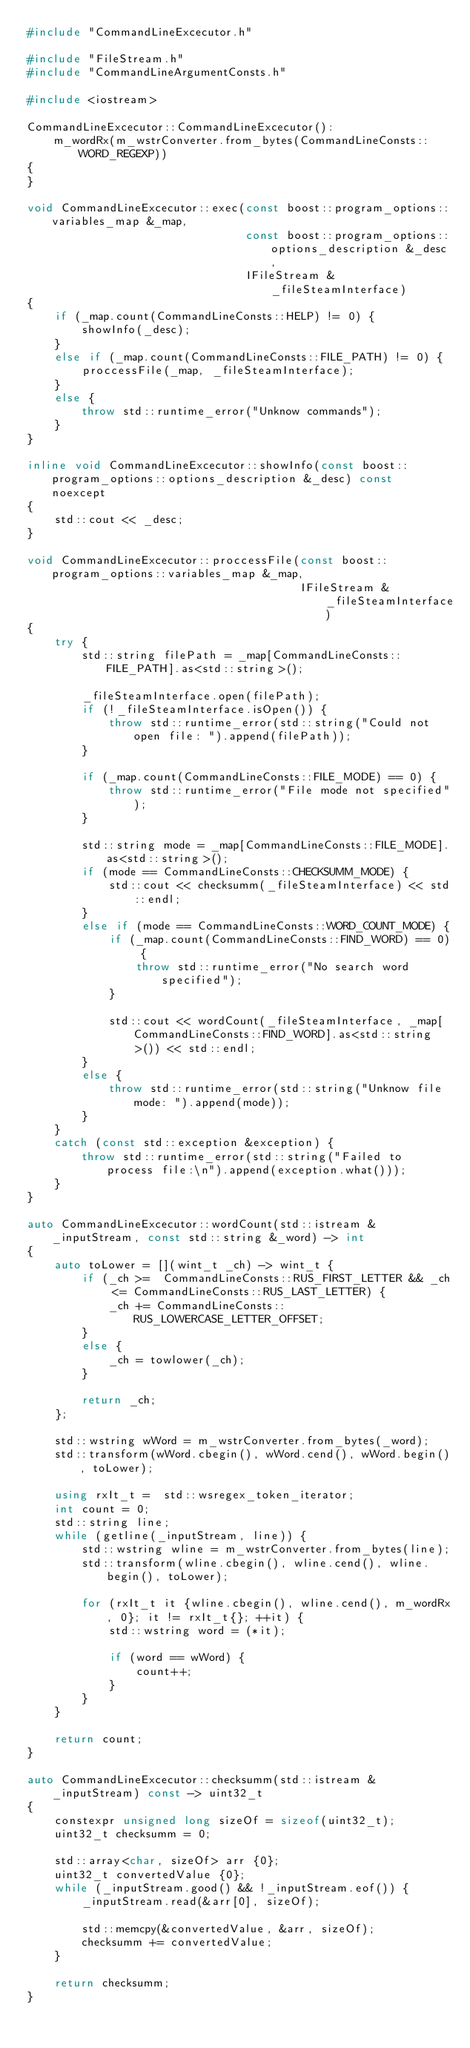<code> <loc_0><loc_0><loc_500><loc_500><_C++_>#include "CommandLineExcecutor.h"

#include "FileStream.h"
#include "CommandLineArgumentConsts.h"

#include <iostream>

CommandLineExcecutor::CommandLineExcecutor():
    m_wordRx(m_wstrConverter.from_bytes(CommandLineConsts::WORD_REGEXP))
{
}

void CommandLineExcecutor::exec(const boost::program_options::variables_map &_map,
                                const boost::program_options::options_description &_desc,
                                IFileStream &_fileSteamInterface)
{
    if (_map.count(CommandLineConsts::HELP) != 0) {
        showInfo(_desc);
    }
    else if (_map.count(CommandLineConsts::FILE_PATH) != 0) {
        proccessFile(_map, _fileSteamInterface);
    }
    else {
        throw std::runtime_error("Unknow commands");
    }
}

inline void CommandLineExcecutor::showInfo(const boost::program_options::options_description &_desc) const noexcept
{
    std::cout << _desc;
}

void CommandLineExcecutor::proccessFile(const boost::program_options::variables_map &_map,
                                        IFileStream &_fileSteamInterface)
{
    try {
        std::string filePath = _map[CommandLineConsts::FILE_PATH].as<std::string>();

        _fileSteamInterface.open(filePath);
        if (!_fileSteamInterface.isOpen()) {
            throw std::runtime_error(std::string("Could not open file: ").append(filePath));
        }

        if (_map.count(CommandLineConsts::FILE_MODE) == 0) {
            throw std::runtime_error("File mode not specified");
        }

        std::string mode = _map[CommandLineConsts::FILE_MODE].as<std::string>();
        if (mode == CommandLineConsts::CHECKSUMM_MODE) {
            std::cout << checksumm(_fileSteamInterface) << std::endl;
        }
        else if (mode == CommandLineConsts::WORD_COUNT_MODE) {
            if (_map.count(CommandLineConsts::FIND_WORD) == 0) {
                throw std::runtime_error("No search word specified");
            }

            std::cout << wordCount(_fileSteamInterface, _map[CommandLineConsts::FIND_WORD].as<std::string>()) << std::endl;
        }
        else {
            throw std::runtime_error(std::string("Unknow file mode: ").append(mode));
        }
    }
    catch (const std::exception &exception) {
        throw std::runtime_error(std::string("Failed to process file:\n").append(exception.what()));
    }
}

auto CommandLineExcecutor::wordCount(std::istream &_inputStream, const std::string &_word) -> int
{
    auto toLower = [](wint_t _ch) -> wint_t {
        if (_ch >=  CommandLineConsts::RUS_FIRST_LETTER && _ch <= CommandLineConsts::RUS_LAST_LETTER) {
            _ch += CommandLineConsts::RUS_LOWERCASE_LETTER_OFFSET;
        }
        else {
            _ch = towlower(_ch);
        }

        return _ch;
    };

    std::wstring wWord = m_wstrConverter.from_bytes(_word);
    std::transform(wWord.cbegin(), wWord.cend(), wWord.begin(), toLower);

    using rxIt_t =  std::wsregex_token_iterator;
    int count = 0;
    std::string line;
    while (getline(_inputStream, line)) {
        std::wstring wline = m_wstrConverter.from_bytes(line);
        std::transform(wline.cbegin(), wline.cend(), wline.begin(), toLower);

        for (rxIt_t it {wline.cbegin(), wline.cend(), m_wordRx, 0}; it != rxIt_t{}; ++it) {
            std::wstring word = (*it);

            if (word == wWord) {
                count++;
            }
        }
    }

    return count;
}

auto CommandLineExcecutor::checksumm(std::istream &_inputStream) const -> uint32_t
{
    constexpr unsigned long sizeOf = sizeof(uint32_t);
    uint32_t checksumm = 0;

    std::array<char, sizeOf> arr {0};
    uint32_t convertedValue {0};
    while (_inputStream.good() && !_inputStream.eof()) {
        _inputStream.read(&arr[0], sizeOf);

        std::memcpy(&convertedValue, &arr, sizeOf);
        checksumm += convertedValue;
    }

    return checksumm;
}
</code> 